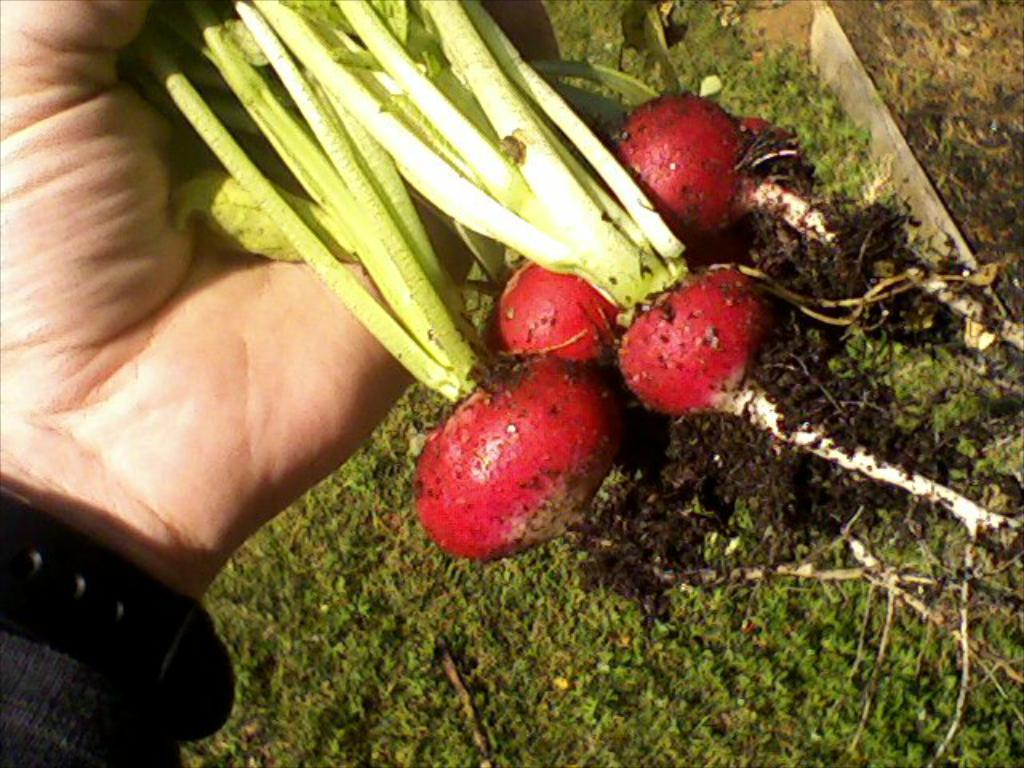What is the main subject of the image? The main subject of the image is beetroots. How are the beetroots being held in the image? The beetroots are being held by a person. What can be seen in the background of the image? There is grass in the background of the image. What type of club is being used to hit the beetroots in the image? There is no club present in the image, and the beetroots are not being hit. 